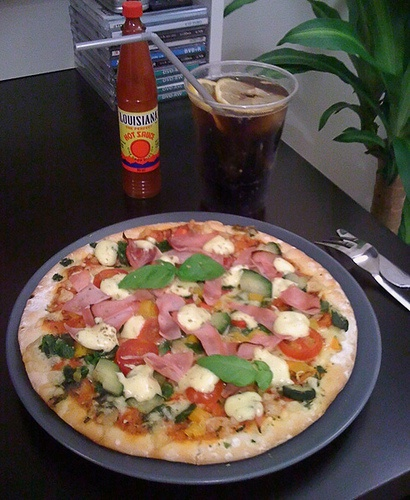Describe the objects in this image and their specific colors. I can see pizza in purple, tan, and brown tones, potted plant in purple, black, darkgreen, gray, and teal tones, cup in purple, black, gray, darkgray, and maroon tones, bottle in purple, maroon, black, brown, and tan tones, and fork in purple, darkgray, gray, lavender, and black tones in this image. 